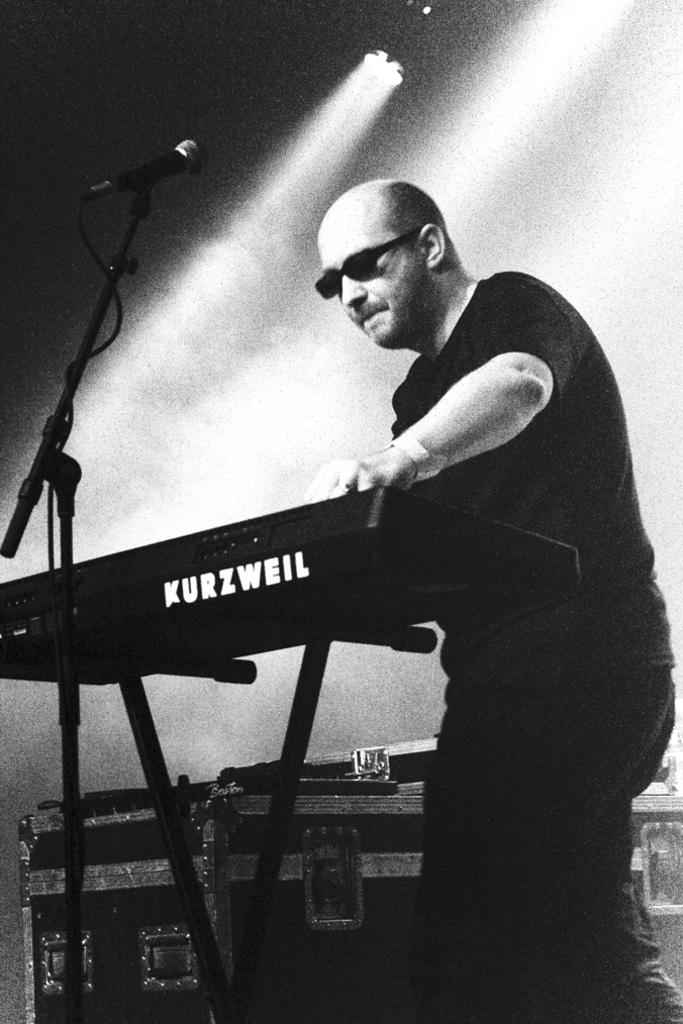What is the main subject of the image? There is a person in the image. What is the person wearing? The person is wearing a black dress and glasses. What object is in front of the person? There is a microphone in front of the person. What other items can be seen in the image? There are musical instruments and lights in the background of the image. What type of oil can be seen dripping from the turkey in the image? There is no turkey or oil present in the image. What time of day is depicted in the image? The provided facts do not mention the time of day, so it cannot be determined from the image. 